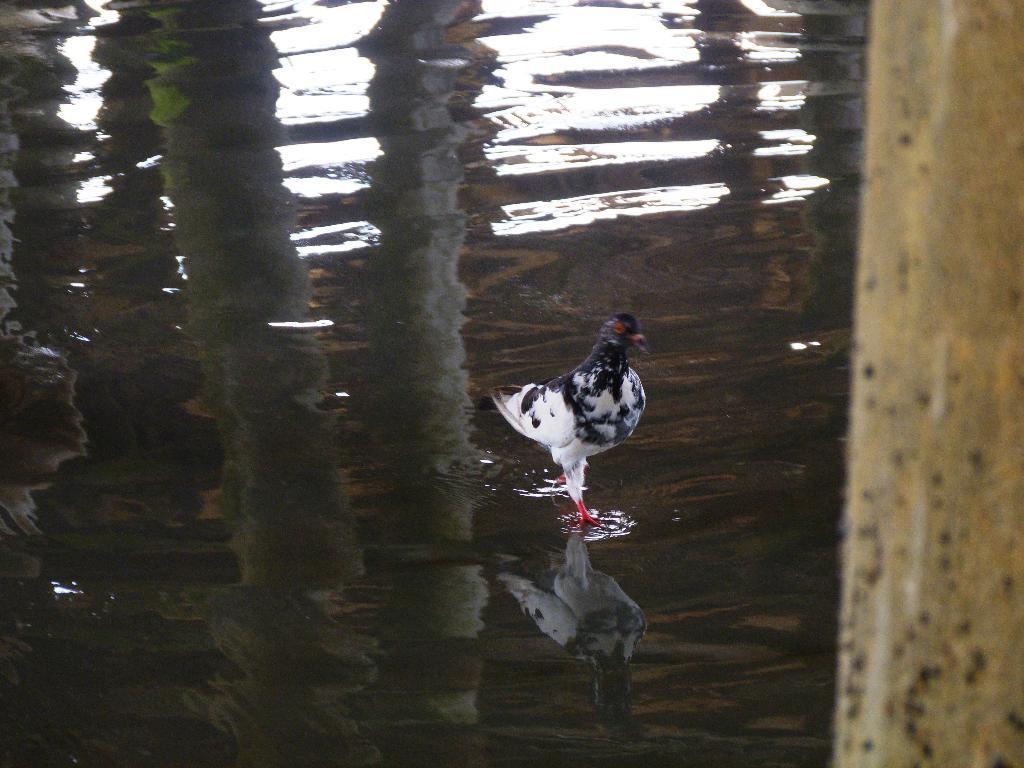Describe this image in one or two sentences. In this image I can see the hen which is in black and white color. It is standing on the water. To the right I can see the pole. 